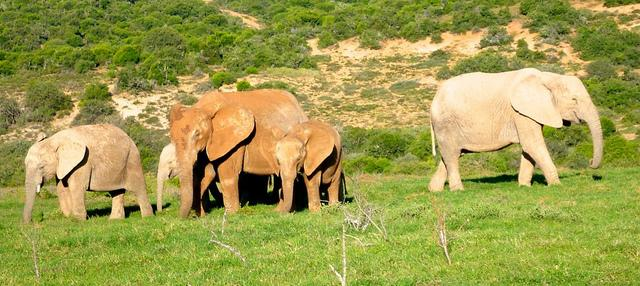What color is the elephant on the right?

Choices:
A) brown
B) pink
C) gray
D) white white 